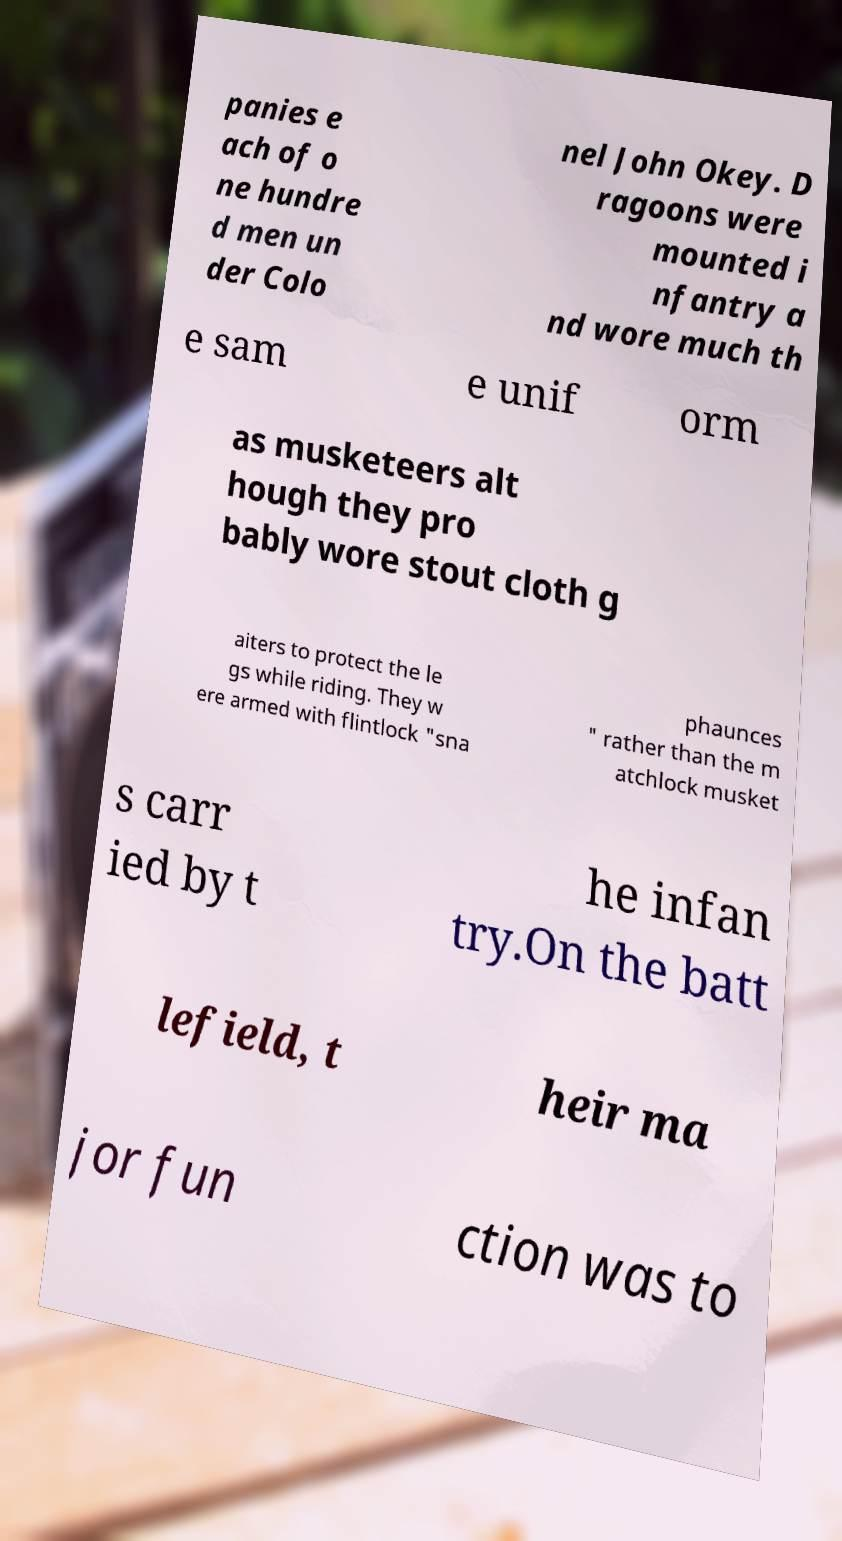What messages or text are displayed in this image? I need them in a readable, typed format. panies e ach of o ne hundre d men un der Colo nel John Okey. D ragoons were mounted i nfantry a nd wore much th e sam e unif orm as musketeers alt hough they pro bably wore stout cloth g aiters to protect the le gs while riding. They w ere armed with flintlock "sna phaunces " rather than the m atchlock musket s carr ied by t he infan try.On the batt lefield, t heir ma jor fun ction was to 